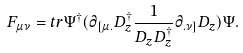<formula> <loc_0><loc_0><loc_500><loc_500>F _ { \mu \nu } = t r \Psi ^ { \dagger } ( \partial _ { [ \mu . } D _ { z } ^ { \dagger } \frac { 1 } { D _ { z } D _ { z } ^ { \dagger } } \partial _ { . \nu ] } D _ { z } ) \Psi .</formula> 